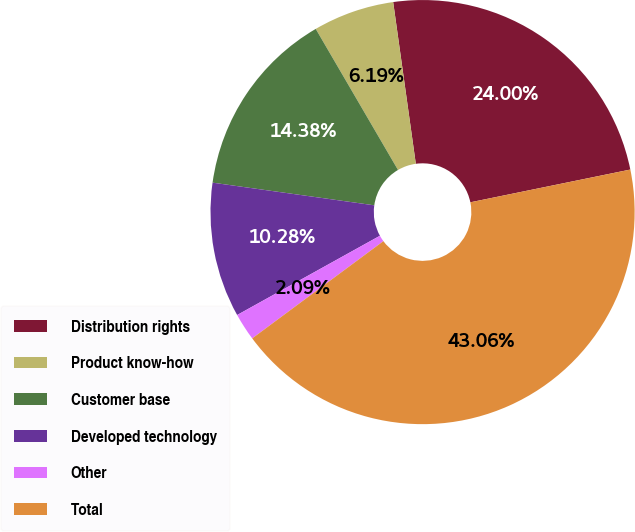Convert chart. <chart><loc_0><loc_0><loc_500><loc_500><pie_chart><fcel>Distribution rights<fcel>Product know-how<fcel>Customer base<fcel>Developed technology<fcel>Other<fcel>Total<nl><fcel>24.0%<fcel>6.19%<fcel>14.38%<fcel>10.28%<fcel>2.09%<fcel>43.06%<nl></chart> 